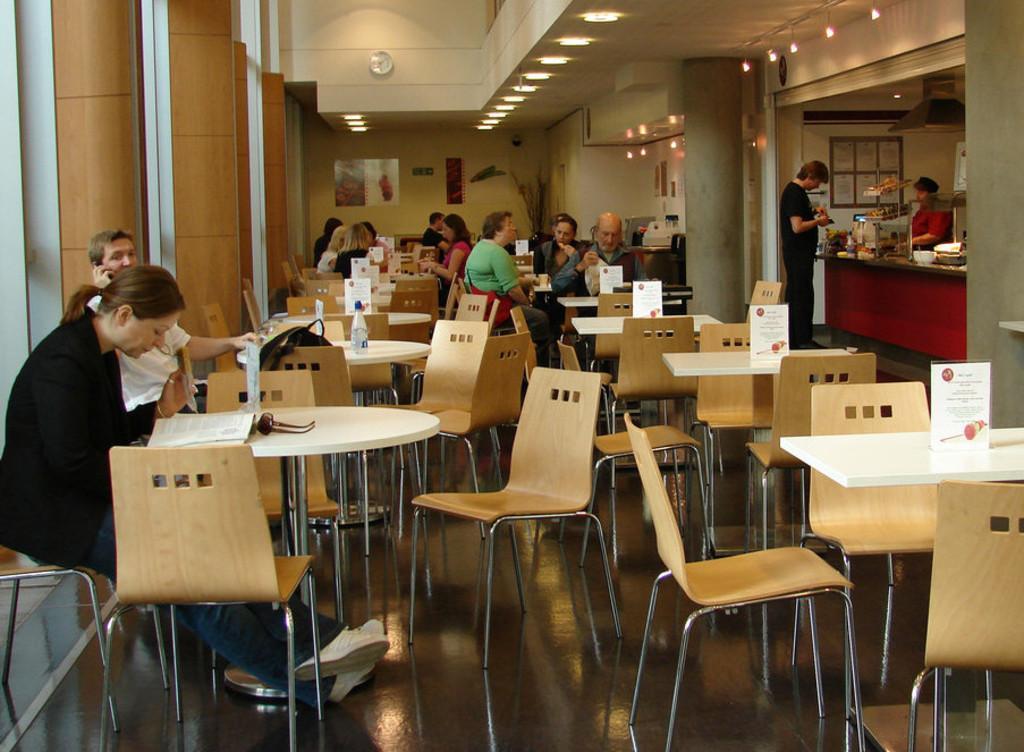Could you give a brief overview of what you see in this image? In this image there are group of people sitting and two persons are standing. At the top there is a clock and lights. At the back there is a frame and in the middle of the image there are many tables and chairs. 